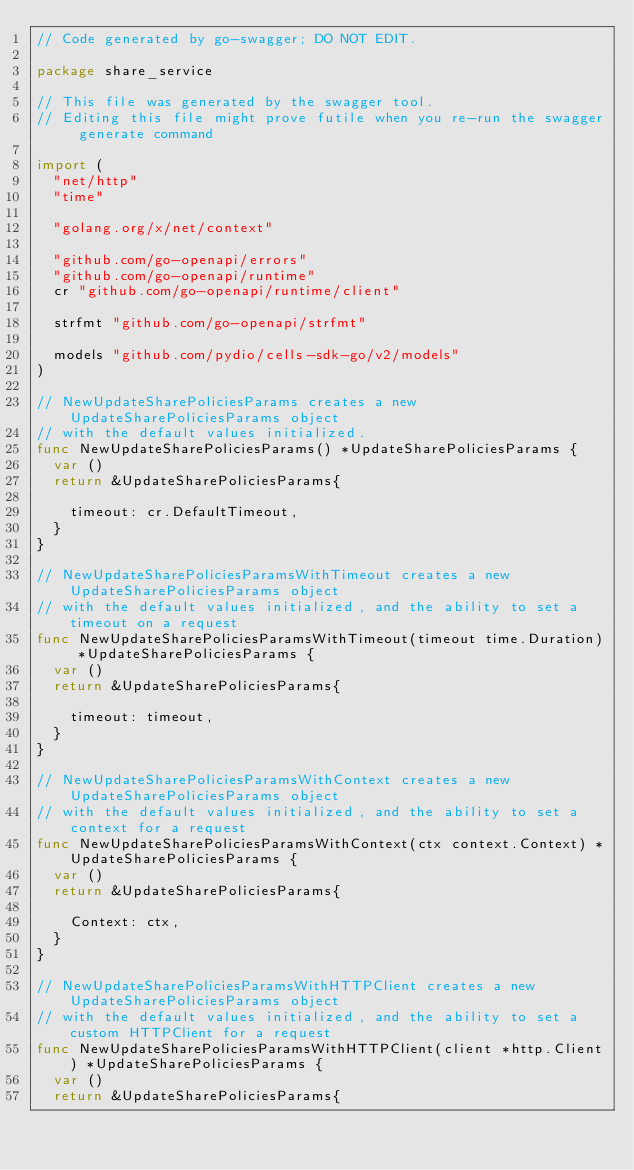<code> <loc_0><loc_0><loc_500><loc_500><_Go_>// Code generated by go-swagger; DO NOT EDIT.

package share_service

// This file was generated by the swagger tool.
// Editing this file might prove futile when you re-run the swagger generate command

import (
	"net/http"
	"time"

	"golang.org/x/net/context"

	"github.com/go-openapi/errors"
	"github.com/go-openapi/runtime"
	cr "github.com/go-openapi/runtime/client"

	strfmt "github.com/go-openapi/strfmt"

	models "github.com/pydio/cells-sdk-go/v2/models"
)

// NewUpdateSharePoliciesParams creates a new UpdateSharePoliciesParams object
// with the default values initialized.
func NewUpdateSharePoliciesParams() *UpdateSharePoliciesParams {
	var ()
	return &UpdateSharePoliciesParams{

		timeout: cr.DefaultTimeout,
	}
}

// NewUpdateSharePoliciesParamsWithTimeout creates a new UpdateSharePoliciesParams object
// with the default values initialized, and the ability to set a timeout on a request
func NewUpdateSharePoliciesParamsWithTimeout(timeout time.Duration) *UpdateSharePoliciesParams {
	var ()
	return &UpdateSharePoliciesParams{

		timeout: timeout,
	}
}

// NewUpdateSharePoliciesParamsWithContext creates a new UpdateSharePoliciesParams object
// with the default values initialized, and the ability to set a context for a request
func NewUpdateSharePoliciesParamsWithContext(ctx context.Context) *UpdateSharePoliciesParams {
	var ()
	return &UpdateSharePoliciesParams{

		Context: ctx,
	}
}

// NewUpdateSharePoliciesParamsWithHTTPClient creates a new UpdateSharePoliciesParams object
// with the default values initialized, and the ability to set a custom HTTPClient for a request
func NewUpdateSharePoliciesParamsWithHTTPClient(client *http.Client) *UpdateSharePoliciesParams {
	var ()
	return &UpdateSharePoliciesParams{</code> 